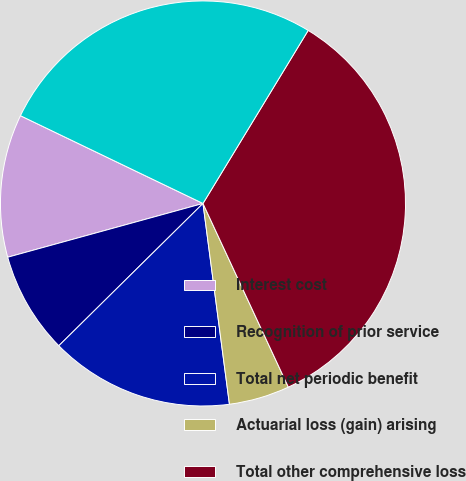Convert chart to OTSL. <chart><loc_0><loc_0><loc_500><loc_500><pie_chart><fcel>Interest cost<fcel>Recognition of prior service<fcel>Total net periodic benefit<fcel>Actuarial loss (gain) arising<fcel>Total other comprehensive loss<fcel>Total recognized<nl><fcel>11.41%<fcel>8.12%<fcel>14.69%<fcel>4.84%<fcel>34.38%<fcel>26.56%<nl></chart> 